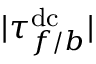Convert formula to latex. <formula><loc_0><loc_0><loc_500><loc_500>| \tau _ { f / b } ^ { d c } |</formula> 